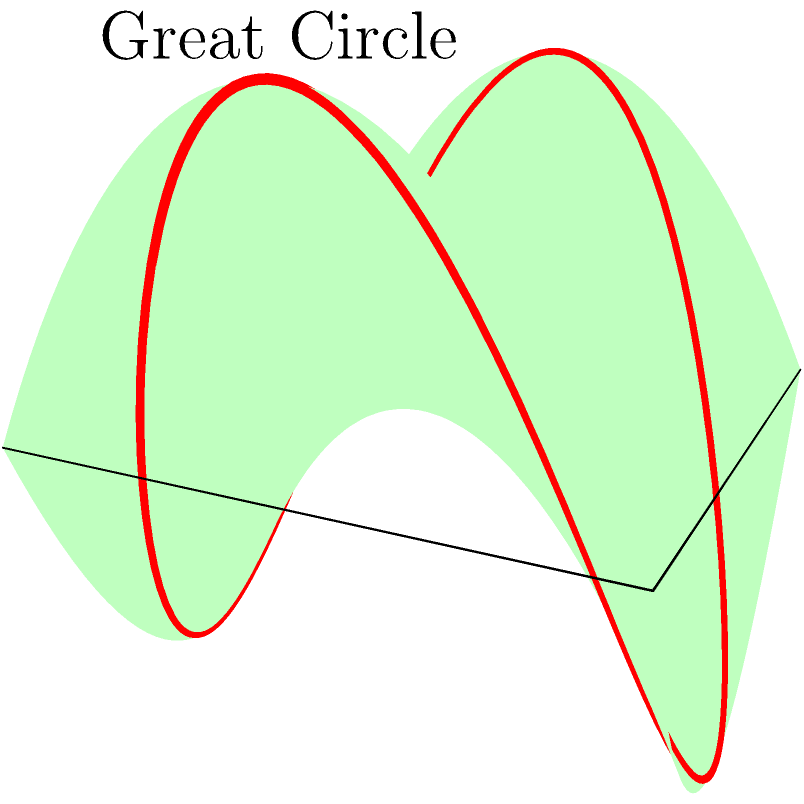In your farm-to-table restaurant, you're designing a hyperbolic paraboloid-shaped serving dish. A great circle on this surface represents the optimal path for arranging locally-sourced ingredients. If the dish's surface is described by the equation $z = x^2 - y^2$, what is the maximum height reached by the great circle shown in red, assuming the dish has a radius of 2 units? Let's approach this step-by-step:

1) The surface of the dish is described by $z = x^2 - y^2$, which is a hyperbolic paraboloid.

2) The great circle shown is the intersection of this surface with a vertical plane passing through the origin.

3) Due to the symmetry of the hyperbolic paraboloid, this plane can be described by the equation $y = kx$, where $k$ is some constant.

4) Substituting this into the surface equation:
   $z = x^2 - (kx)^2 = x^2(1-k^2)$

5) The great circle reaches its maximum height when $x$ is at its maximum value, which is the radius of the dish, 2 units.

6) Therefore, the maximum height is:
   $z_{max} = (2)^2(1-k^2) = 4(1-k^2)$

7) To find $k$, we need to consider that the great circle passes through the points $(2,0,4)$ and $(0,2,-4)$ on the surface.

8) Using the point $(2,0,4)$:
   $4 = 4(1-k^2)$
   $1 = 1-k^2$
   $k^2 = 0$
   $k = 0$

9) This confirms that the plane is actually the $xz$-plane ($y=0$).

10) Substituting $k=0$ into the maximum height equation:
    $z_{max} = 4(1-0^2) = 4$

Therefore, the maximum height reached by the great circle is 4 units.
Answer: 4 units 